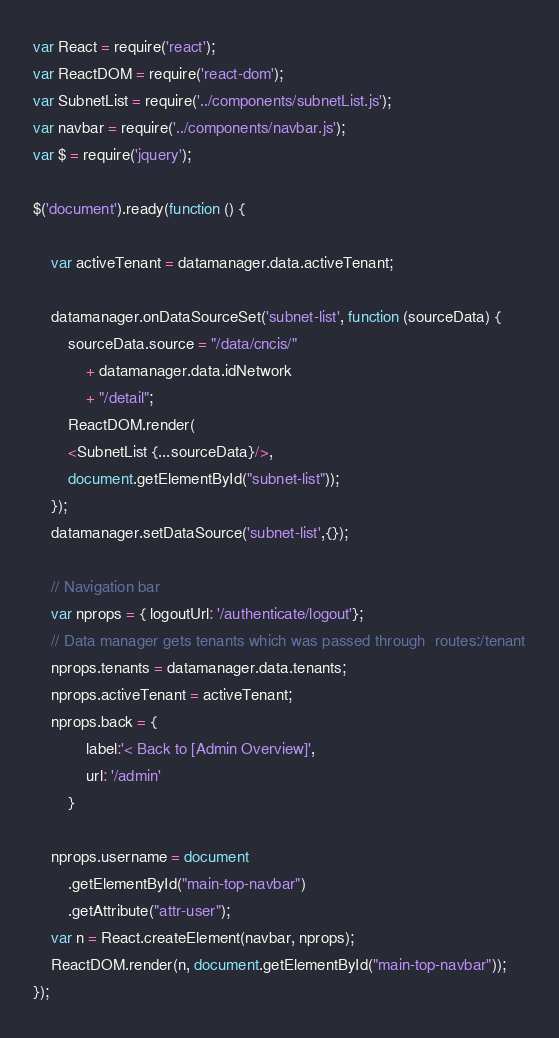<code> <loc_0><loc_0><loc_500><loc_500><_JavaScript_>var React = require('react');
var ReactDOM = require('react-dom');
var SubnetList = require('../components/subnetList.js');
var navbar = require('../components/navbar.js');
var $ = require('jquery');

$('document').ready(function () {

    var activeTenant = datamanager.data.activeTenant;

    datamanager.onDataSourceSet('subnet-list', function (sourceData) {
        sourceData.source = "/data/cncis/"
            + datamanager.data.idNetwork
            + "/detail";
        ReactDOM.render(
        <SubnetList {...sourceData}/>,
        document.getElementById("subnet-list"));
    });
    datamanager.setDataSource('subnet-list',{});

    // Navigation bar
    var nprops = { logoutUrl: '/authenticate/logout'};
    // Data manager gets tenants which was passed through  routes:/tenant
    nprops.tenants = datamanager.data.tenants;
    nprops.activeTenant = activeTenant;
    nprops.back = {
            label:'< Back to [Admin Overview]',
            url: '/admin'
        }

    nprops.username = document
        .getElementById("main-top-navbar")
        .getAttribute("attr-user");
    var n = React.createElement(navbar, nprops);
    ReactDOM.render(n, document.getElementById("main-top-navbar"));
});
</code> 